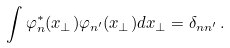Convert formula to latex. <formula><loc_0><loc_0><loc_500><loc_500>\int \varphi ^ { * } _ { n } ( x _ { \perp } ) \varphi _ { n ^ { \prime } } ( x _ { \perp } ) d { x } _ { \perp } = \delta _ { n n ^ { \prime } } \, .</formula> 